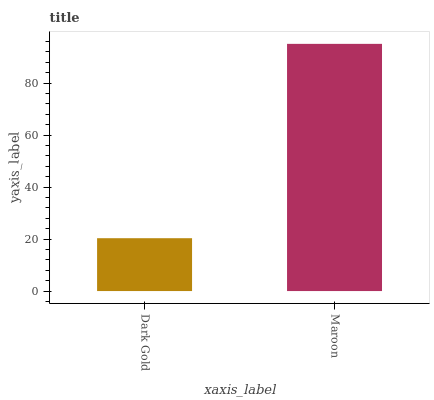Is Maroon the minimum?
Answer yes or no. No. Is Maroon greater than Dark Gold?
Answer yes or no. Yes. Is Dark Gold less than Maroon?
Answer yes or no. Yes. Is Dark Gold greater than Maroon?
Answer yes or no. No. Is Maroon less than Dark Gold?
Answer yes or no. No. Is Maroon the high median?
Answer yes or no. Yes. Is Dark Gold the low median?
Answer yes or no. Yes. Is Dark Gold the high median?
Answer yes or no. No. Is Maroon the low median?
Answer yes or no. No. 